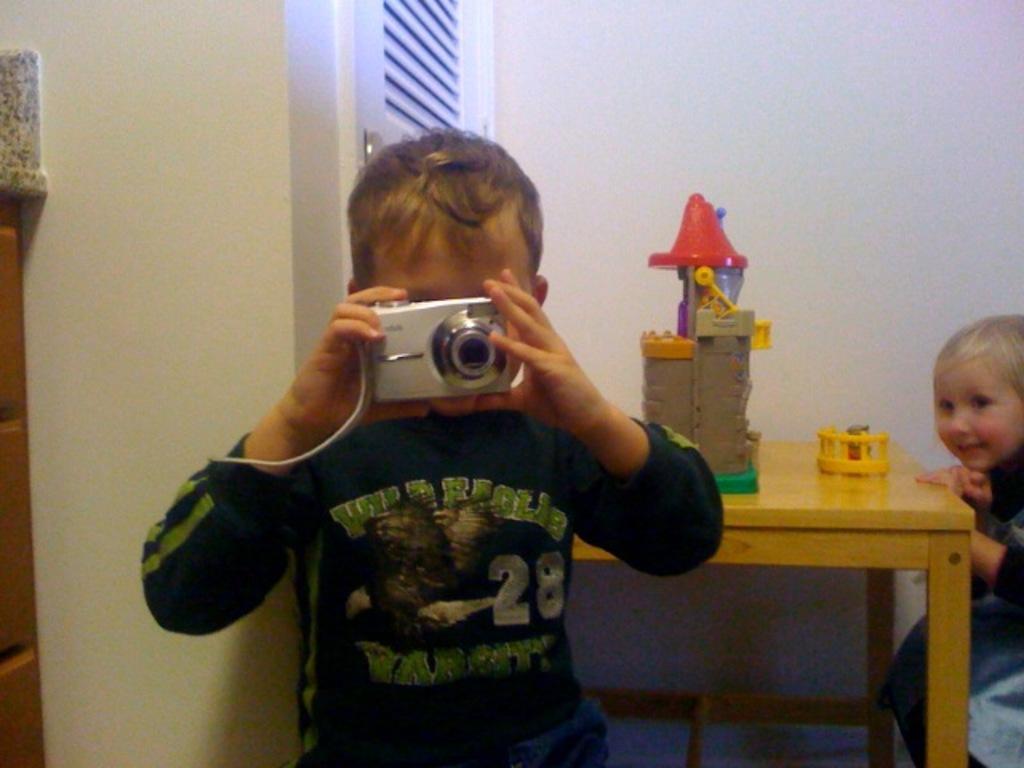In one or two sentences, can you explain what this image depicts? a person is standing, holding a camera in his hand. behind her there is a table on which there are toys. at the right there is a person sitting. 